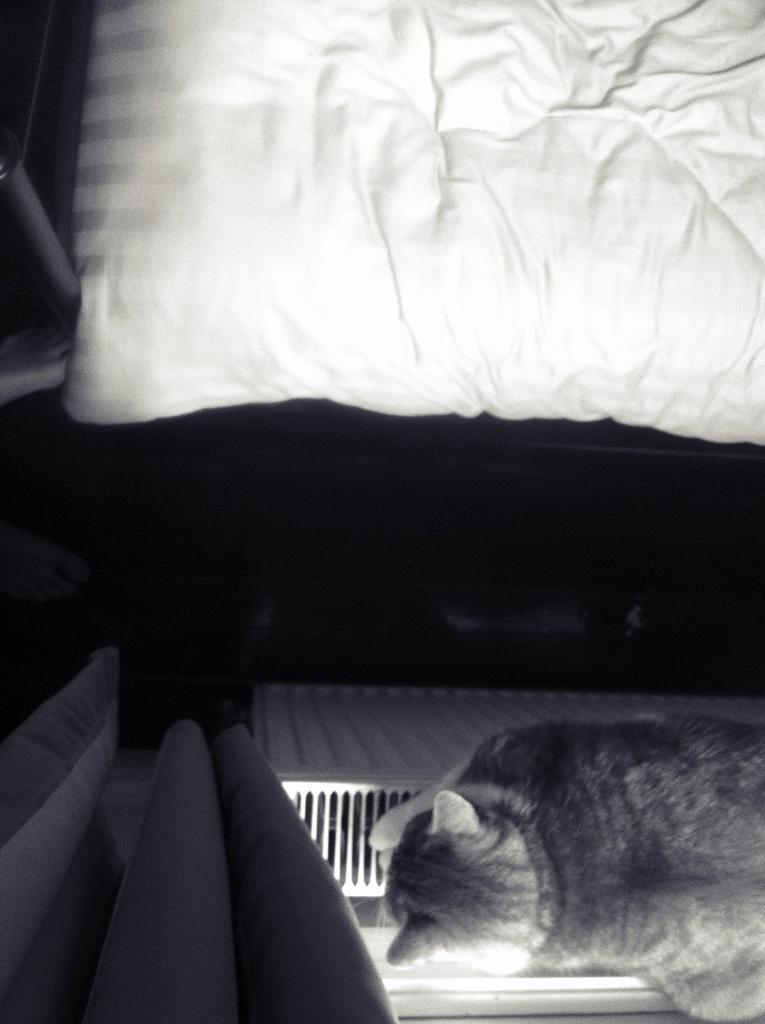What is the color scheme of the image? The image is in black and white color. What type of window treatment can be seen in the image? There are curtains in the image. What animal is present in the image? There is a cat on some object in the image. What type of furniture is visible in the image? There is a bed in the image. What type of reward is the cat holding in the image? There is no reward present in the image; the cat is simply sitting on an object. 